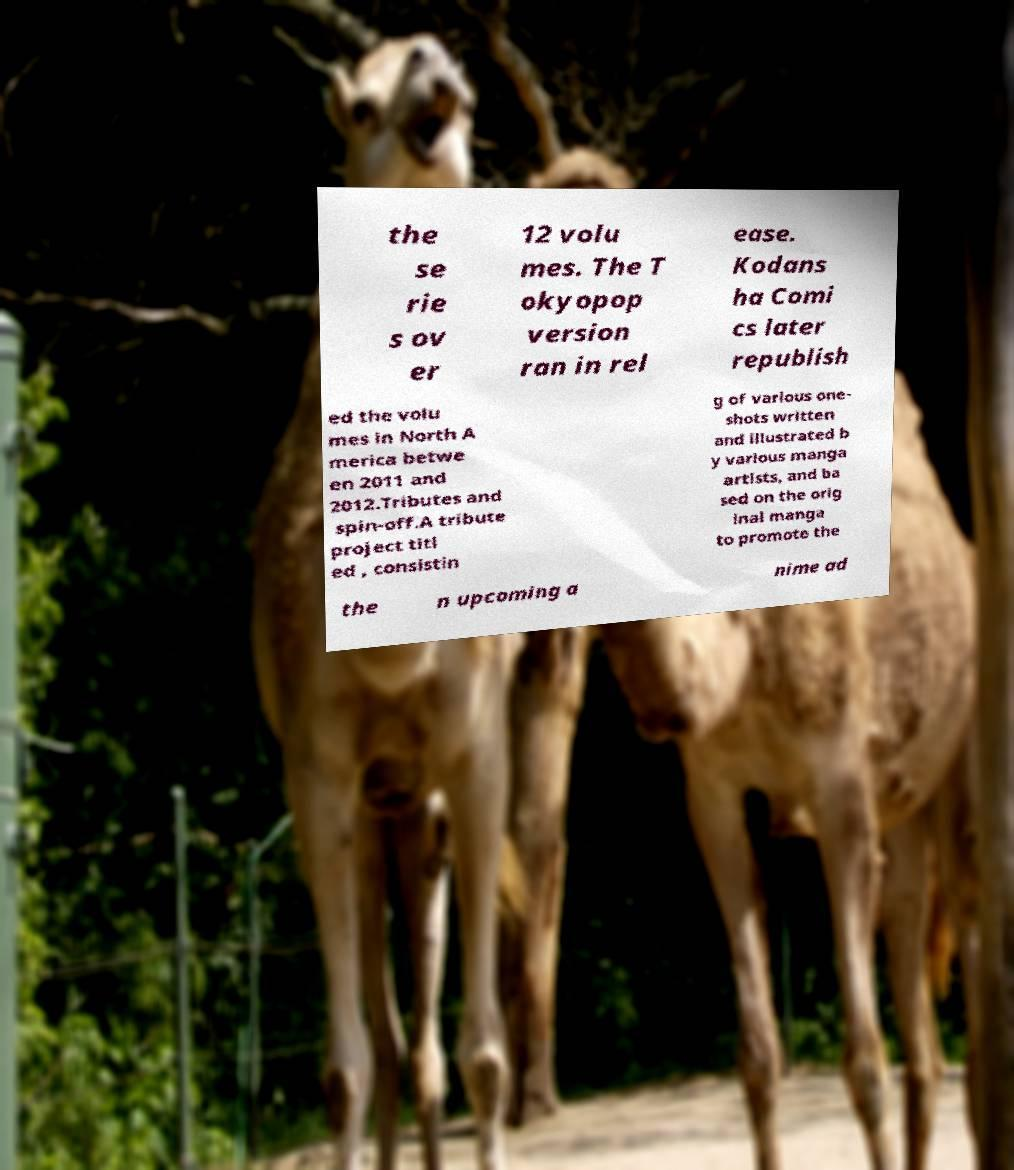What messages or text are displayed in this image? I need them in a readable, typed format. the se rie s ov er 12 volu mes. The T okyopop version ran in rel ease. Kodans ha Comi cs later republish ed the volu mes in North A merica betwe en 2011 and 2012.Tributes and spin-off.A tribute project titl ed , consistin g of various one- shots written and illustrated b y various manga artists, and ba sed on the orig inal manga to promote the the n upcoming a nime ad 